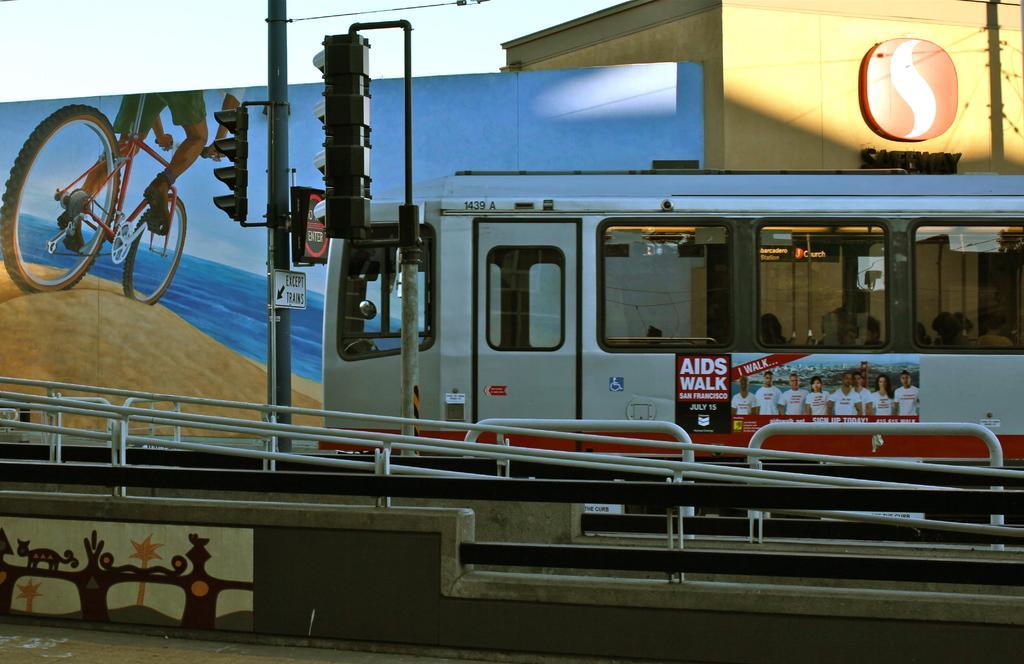How would you summarize this image in a sentence or two? In this picture there is a train in the center which is towards the right. On the train there is some poster. Beside the train there are signal lights. At the bottom, there is a bridge. In the background there is a building and a wall. On the wall, there is some painting. 